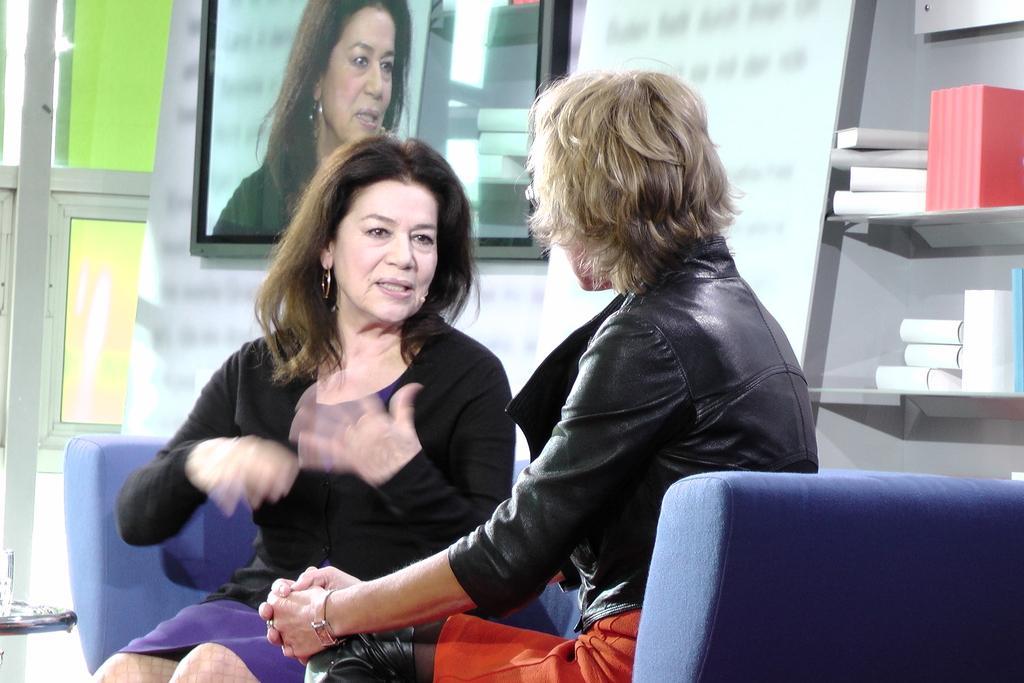Could you give a brief overview of what you see in this image? In this picture there are persons sitting on the sofa which is in the center. On the right side there are objects in the shelves and there is a TV on the wall. In the background there is a window. 